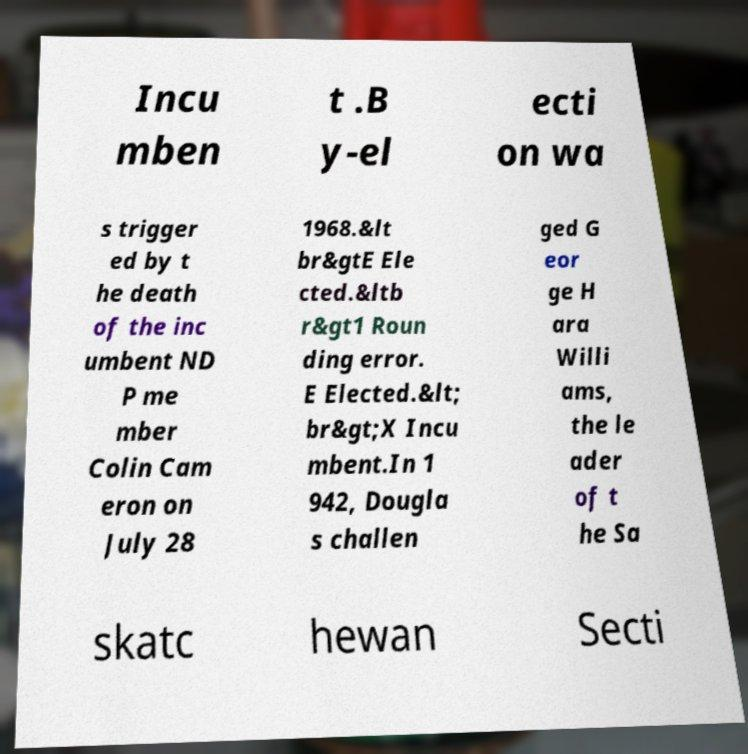Could you extract and type out the text from this image? Incu mben t .B y-el ecti on wa s trigger ed by t he death of the inc umbent ND P me mber Colin Cam eron on July 28 1968.&lt br&gtE Ele cted.&ltb r&gt1 Roun ding error. E Elected.&lt; br&gt;X Incu mbent.In 1 942, Dougla s challen ged G eor ge H ara Willi ams, the le ader of t he Sa skatc hewan Secti 